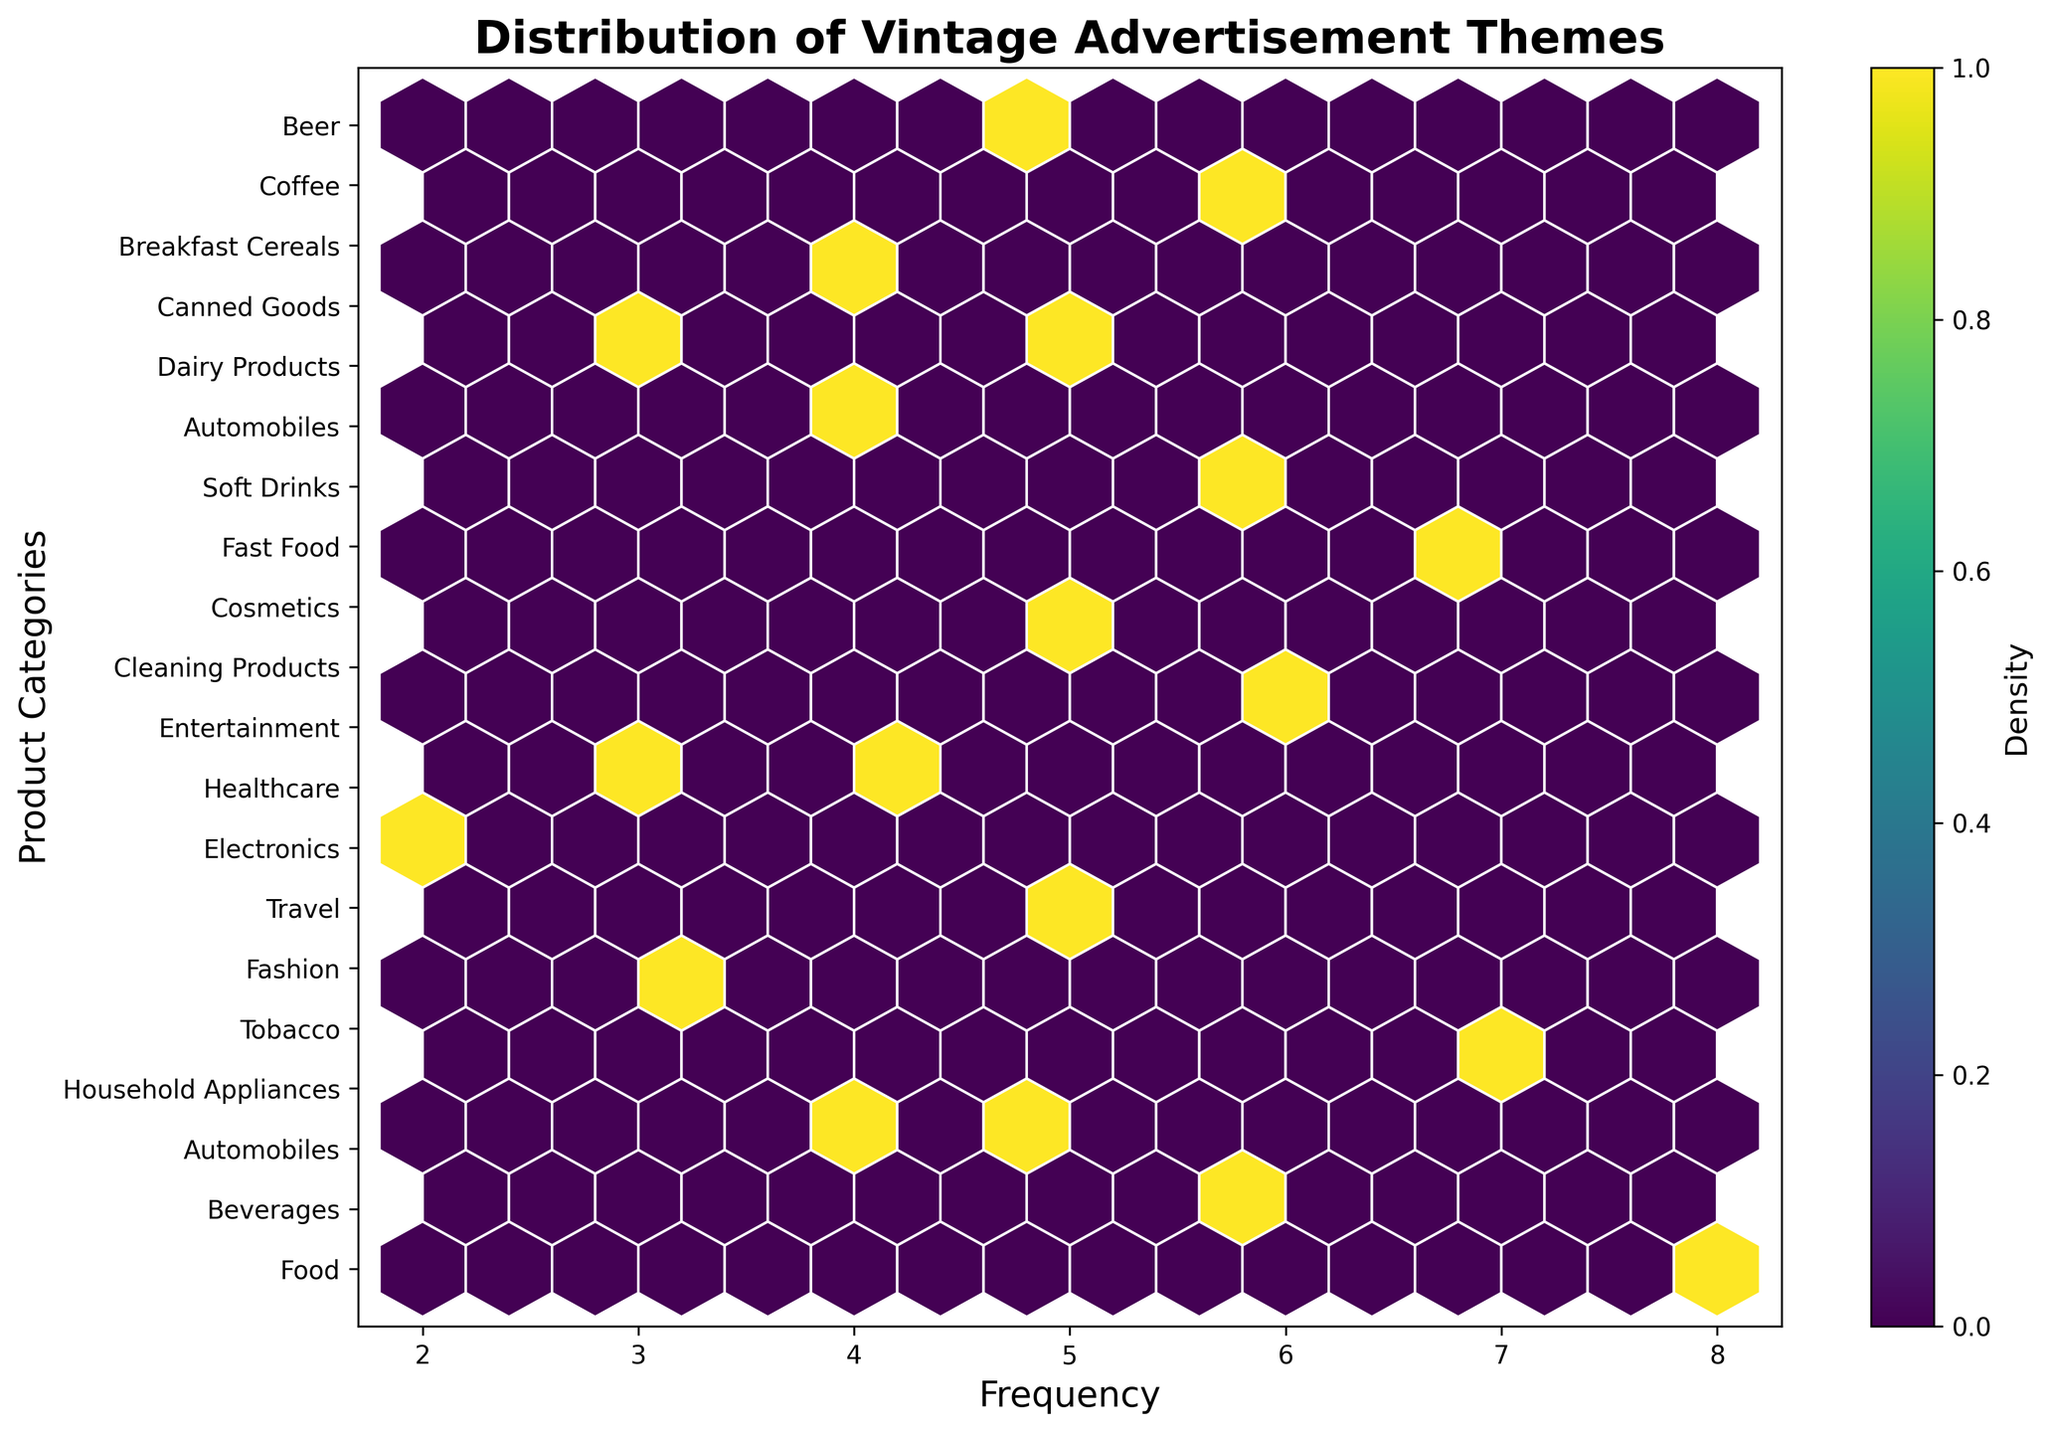What is the title of the hexbin plot? The title is located at the top of the figure and provides a brief description of the plot.
Answer: Distribution of Vintage Advertisement Themes What do the X-axis and Y-axis represent in the hexbin plot? Look at the labels along the X-axis and Y-axis to understand what each axis is depicting.
Answer: The X-axis represents frequency and the Y-axis represents product categories Which product category has the highest frequency of advertisements? Identify the highest value on the X-axis and trace the corresponding Y-axis label.
Answer: Food (Family Dining) How many product categories are represented in the hexbin plot? Count the number of unique labels along the Y-axis.
Answer: 20 What product categories use a color scheme that includes both 'Red' and another color? Look at the product categories along the Y-axis and check for 'Red' mentioned anywhere in their color schemes.
Answer: Food, Automobiles, Fast Food, Canned Goods, Soft Drinks Which advertisement theme is associated with the lowest frequency of advertisements? Identify the point(s) with the lowest value on the X-axis and check the corresponding Y-axis label.
Answer: Electronics (Innovation) What is the average frequency of advertisements for categories with blue in their color scheme? Identify categories with blue in their color scheme, sum up their frequencies, and divide by the total number of those categories. The categories are Beverages, Travel, Healthcare, Dairy Products, and Soft Drinks with frequencies 6, 5, 4, 5, and 6. The sum is 26, and there are 5 categories.
Answer: (6 + 5 + 4 + 5 + 6) / 5 = 5.2 Are there more advertisements for Tobacco or Cleaning Products? Compare the frequencies of advertisements for both categories from the X-axis values. Tobacco has 7 and Cleaning Products has 6.
Answer: Tobacco Which color scheme appears most frequently in the advertisements for Beverages and Soft Drinks combined? Check the color schemes for Beverages (Blue and White) and Soft Drinks (Red and Blue) and note which color appears most often. Blue appears in both.
Answer: Blue What is the most common theme in the highest frequency range of advertisements? Identify the range with the highest density from the hexbin plot and look for the common theme(s) within that range. The highest frequencies are 8 and 7 for Food and Fast Food. Their themes are Family Dining and Convenience.
Answer: Family Dining and Convenience 